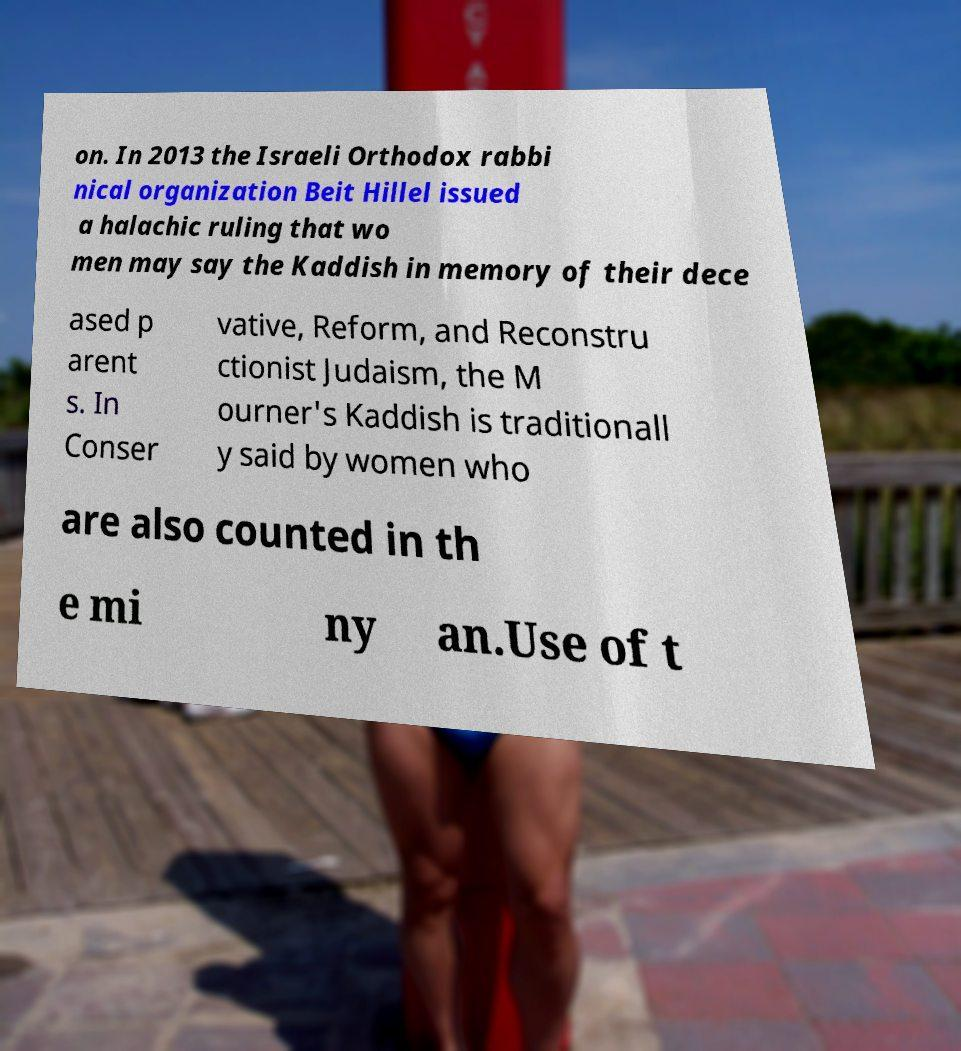What messages or text are displayed in this image? I need them in a readable, typed format. on. In 2013 the Israeli Orthodox rabbi nical organization Beit Hillel issued a halachic ruling that wo men may say the Kaddish in memory of their dece ased p arent s. In Conser vative, Reform, and Reconstru ctionist Judaism, the M ourner's Kaddish is traditionall y said by women who are also counted in th e mi ny an.Use of t 